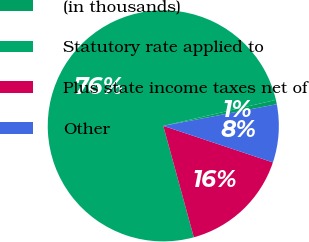<chart> <loc_0><loc_0><loc_500><loc_500><pie_chart><fcel>(in thousands)<fcel>Statutory rate applied to<fcel>Plus state income taxes net of<fcel>Other<nl><fcel>0.61%<fcel>75.65%<fcel>15.62%<fcel>8.12%<nl></chart> 